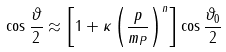Convert formula to latex. <formula><loc_0><loc_0><loc_500><loc_500>\cos \frac { \vartheta } { 2 } \approx \left [ 1 + \kappa \left ( \frac { p } { m _ { P } } \right ) ^ { n } \right ] \cos \frac { \vartheta _ { 0 } } { 2 }</formula> 